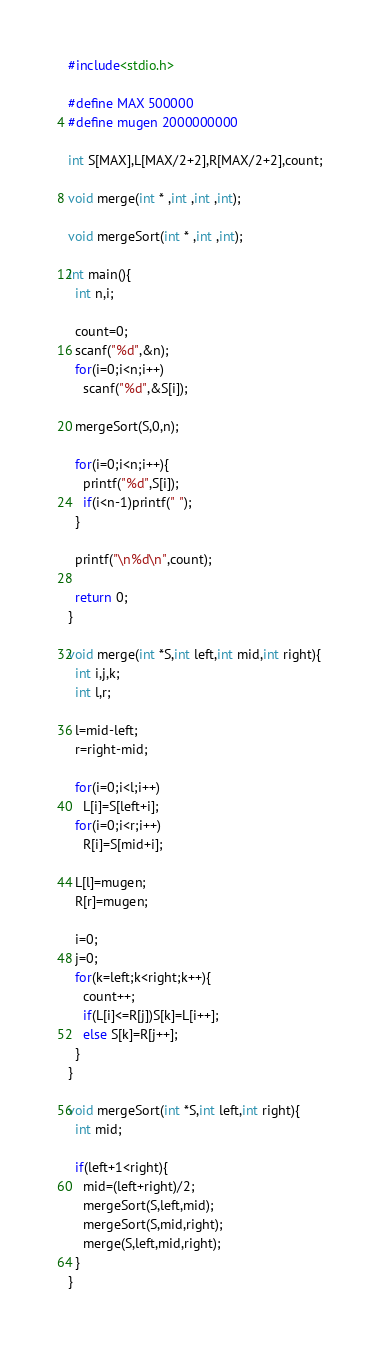Convert code to text. <code><loc_0><loc_0><loc_500><loc_500><_C_>#include<stdio.h>

#define MAX 500000
#define mugen 2000000000

int S[MAX],L[MAX/2+2],R[MAX/2+2],count;

void merge(int * ,int ,int ,int);

void mergeSort(int * ,int ,int);

int main(){
  int n,i;

  count=0;
  scanf("%d",&n);
  for(i=0;i<n;i++)
    scanf("%d",&S[i]);

  mergeSort(S,0,n);

  for(i=0;i<n;i++){
    printf("%d",S[i]);
    if(i<n-1)printf(" ");
  }

  printf("\n%d\n",count);

  return 0;
}

void merge(int *S,int left,int mid,int right){
  int i,j,k;
  int l,r;

  l=mid-left;
  r=right-mid;

  for(i=0;i<l;i++)
    L[i]=S[left+i];
  for(i=0;i<r;i++)
    R[i]=S[mid+i];

  L[l]=mugen;
  R[r]=mugen;

  i=0;
  j=0;
  for(k=left;k<right;k++){
    count++;
    if(L[i]<=R[j])S[k]=L[i++];
    else S[k]=R[j++];
  }
}

void mergeSort(int *S,int left,int right){
  int mid;
 
  if(left+1<right){
    mid=(left+right)/2;
    mergeSort(S,left,mid);
    mergeSort(S,mid,right);
    merge(S,left,mid,right);
  }
}</code> 